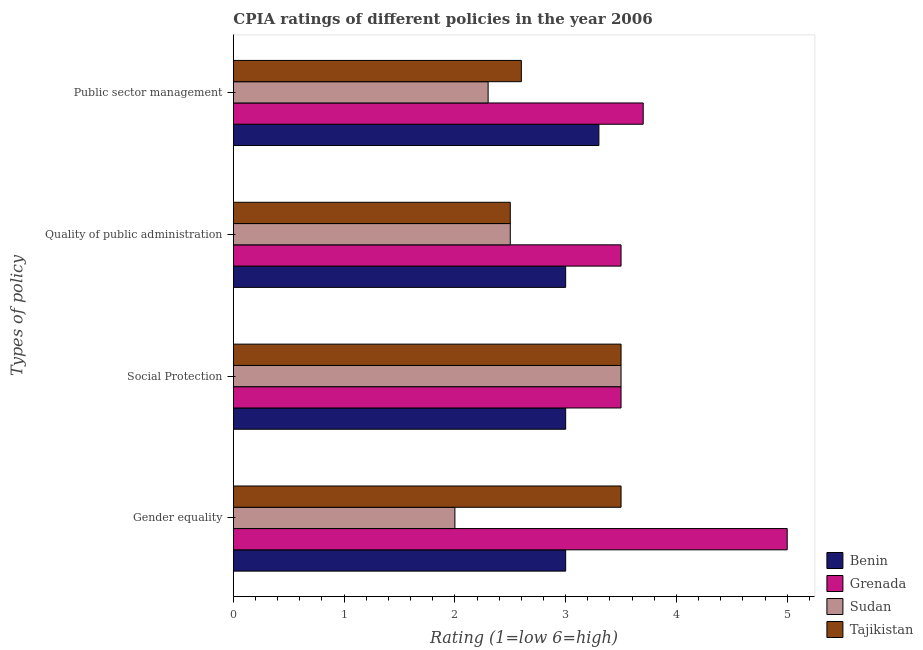How many different coloured bars are there?
Offer a terse response. 4. Are the number of bars on each tick of the Y-axis equal?
Your answer should be very brief. Yes. How many bars are there on the 2nd tick from the top?
Your response must be concise. 4. What is the label of the 4th group of bars from the top?
Give a very brief answer. Gender equality. In which country was the cpia rating of quality of public administration maximum?
Ensure brevity in your answer.  Grenada. In which country was the cpia rating of gender equality minimum?
Provide a succinct answer. Sudan. What is the total cpia rating of gender equality in the graph?
Your response must be concise. 13.5. What is the difference between the cpia rating of social protection in Tajikistan and that in Benin?
Offer a very short reply. 0.5. What is the difference between the cpia rating of quality of public administration in Tajikistan and the cpia rating of public sector management in Sudan?
Ensure brevity in your answer.  0.2. What is the average cpia rating of public sector management per country?
Your response must be concise. 2.98. What is the difference between the cpia rating of social protection and cpia rating of quality of public administration in Grenada?
Offer a very short reply. 0. In how many countries, is the cpia rating of quality of public administration greater than 1.6 ?
Provide a succinct answer. 4. What is the ratio of the cpia rating of quality of public administration in Sudan to that in Grenada?
Your answer should be very brief. 0.71. Is the cpia rating of quality of public administration in Tajikistan less than that in Sudan?
Offer a terse response. No. What is the difference between the highest and the lowest cpia rating of public sector management?
Provide a short and direct response. 1.4. Is the sum of the cpia rating of public sector management in Grenada and Sudan greater than the maximum cpia rating of gender equality across all countries?
Your answer should be compact. Yes. What does the 3rd bar from the top in Quality of public administration represents?
Your answer should be very brief. Grenada. What does the 4th bar from the bottom in Public sector management represents?
Provide a short and direct response. Tajikistan. Is it the case that in every country, the sum of the cpia rating of gender equality and cpia rating of social protection is greater than the cpia rating of quality of public administration?
Make the answer very short. Yes. How many bars are there?
Provide a succinct answer. 16. Are all the bars in the graph horizontal?
Your answer should be very brief. Yes. Does the graph contain grids?
Make the answer very short. No. Where does the legend appear in the graph?
Give a very brief answer. Bottom right. How many legend labels are there?
Offer a very short reply. 4. How are the legend labels stacked?
Offer a terse response. Vertical. What is the title of the graph?
Give a very brief answer. CPIA ratings of different policies in the year 2006. Does "Hong Kong" appear as one of the legend labels in the graph?
Make the answer very short. No. What is the label or title of the Y-axis?
Offer a terse response. Types of policy. What is the Rating (1=low 6=high) of Benin in Gender equality?
Your response must be concise. 3. What is the Rating (1=low 6=high) of Grenada in Gender equality?
Give a very brief answer. 5. What is the Rating (1=low 6=high) in Grenada in Social Protection?
Give a very brief answer. 3.5. What is the Rating (1=low 6=high) of Sudan in Social Protection?
Ensure brevity in your answer.  3.5. What is the Rating (1=low 6=high) of Benin in Quality of public administration?
Make the answer very short. 3. What is the Rating (1=low 6=high) of Grenada in Quality of public administration?
Offer a terse response. 3.5. What is the Rating (1=low 6=high) in Benin in Public sector management?
Give a very brief answer. 3.3. What is the Rating (1=low 6=high) of Grenada in Public sector management?
Provide a short and direct response. 3.7. Across all Types of policy, what is the maximum Rating (1=low 6=high) of Sudan?
Give a very brief answer. 3.5. Across all Types of policy, what is the maximum Rating (1=low 6=high) in Tajikistan?
Keep it short and to the point. 3.5. Across all Types of policy, what is the minimum Rating (1=low 6=high) in Tajikistan?
Your response must be concise. 2.5. What is the total Rating (1=low 6=high) of Benin in the graph?
Your answer should be compact. 12.3. What is the total Rating (1=low 6=high) in Grenada in the graph?
Make the answer very short. 15.7. What is the total Rating (1=low 6=high) of Tajikistan in the graph?
Provide a short and direct response. 12.1. What is the difference between the Rating (1=low 6=high) of Tajikistan in Gender equality and that in Social Protection?
Offer a terse response. 0. What is the difference between the Rating (1=low 6=high) of Grenada in Gender equality and that in Quality of public administration?
Ensure brevity in your answer.  1.5. What is the difference between the Rating (1=low 6=high) of Sudan in Gender equality and that in Quality of public administration?
Provide a succinct answer. -0.5. What is the difference between the Rating (1=low 6=high) of Benin in Social Protection and that in Quality of public administration?
Your response must be concise. 0. What is the difference between the Rating (1=low 6=high) of Grenada in Social Protection and that in Quality of public administration?
Provide a succinct answer. 0. What is the difference between the Rating (1=low 6=high) of Tajikistan in Social Protection and that in Quality of public administration?
Provide a succinct answer. 1. What is the difference between the Rating (1=low 6=high) in Benin in Social Protection and that in Public sector management?
Offer a very short reply. -0.3. What is the difference between the Rating (1=low 6=high) of Grenada in Social Protection and that in Public sector management?
Give a very brief answer. -0.2. What is the difference between the Rating (1=low 6=high) of Grenada in Quality of public administration and that in Public sector management?
Offer a very short reply. -0.2. What is the difference between the Rating (1=low 6=high) of Sudan in Quality of public administration and that in Public sector management?
Your answer should be very brief. 0.2. What is the difference between the Rating (1=low 6=high) of Tajikistan in Quality of public administration and that in Public sector management?
Offer a very short reply. -0.1. What is the difference between the Rating (1=low 6=high) of Benin in Gender equality and the Rating (1=low 6=high) of Sudan in Social Protection?
Provide a short and direct response. -0.5. What is the difference between the Rating (1=low 6=high) in Benin in Gender equality and the Rating (1=low 6=high) in Tajikistan in Social Protection?
Your answer should be compact. -0.5. What is the difference between the Rating (1=low 6=high) of Grenada in Gender equality and the Rating (1=low 6=high) of Tajikistan in Social Protection?
Your answer should be very brief. 1.5. What is the difference between the Rating (1=low 6=high) of Benin in Gender equality and the Rating (1=low 6=high) of Tajikistan in Quality of public administration?
Give a very brief answer. 0.5. What is the difference between the Rating (1=low 6=high) in Grenada in Gender equality and the Rating (1=low 6=high) in Sudan in Quality of public administration?
Make the answer very short. 2.5. What is the difference between the Rating (1=low 6=high) in Grenada in Gender equality and the Rating (1=low 6=high) in Tajikistan in Quality of public administration?
Your response must be concise. 2.5. What is the difference between the Rating (1=low 6=high) in Benin in Gender equality and the Rating (1=low 6=high) in Grenada in Public sector management?
Provide a succinct answer. -0.7. What is the difference between the Rating (1=low 6=high) of Benin in Gender equality and the Rating (1=low 6=high) of Sudan in Public sector management?
Give a very brief answer. 0.7. What is the difference between the Rating (1=low 6=high) of Benin in Social Protection and the Rating (1=low 6=high) of Grenada in Quality of public administration?
Give a very brief answer. -0.5. What is the difference between the Rating (1=low 6=high) in Grenada in Social Protection and the Rating (1=low 6=high) in Tajikistan in Quality of public administration?
Provide a succinct answer. 1. What is the difference between the Rating (1=low 6=high) in Benin in Social Protection and the Rating (1=low 6=high) in Sudan in Public sector management?
Provide a short and direct response. 0.7. What is the difference between the Rating (1=low 6=high) in Grenada in Social Protection and the Rating (1=low 6=high) in Sudan in Public sector management?
Your answer should be very brief. 1.2. What is the difference between the Rating (1=low 6=high) in Sudan in Social Protection and the Rating (1=low 6=high) in Tajikistan in Public sector management?
Provide a succinct answer. 0.9. What is the difference between the Rating (1=low 6=high) of Benin in Quality of public administration and the Rating (1=low 6=high) of Sudan in Public sector management?
Your answer should be compact. 0.7. What is the difference between the Rating (1=low 6=high) of Grenada in Quality of public administration and the Rating (1=low 6=high) of Sudan in Public sector management?
Make the answer very short. 1.2. What is the difference between the Rating (1=low 6=high) in Sudan in Quality of public administration and the Rating (1=low 6=high) in Tajikistan in Public sector management?
Ensure brevity in your answer.  -0.1. What is the average Rating (1=low 6=high) of Benin per Types of policy?
Your response must be concise. 3.08. What is the average Rating (1=low 6=high) of Grenada per Types of policy?
Your answer should be compact. 3.92. What is the average Rating (1=low 6=high) in Sudan per Types of policy?
Provide a succinct answer. 2.58. What is the average Rating (1=low 6=high) of Tajikistan per Types of policy?
Ensure brevity in your answer.  3.02. What is the difference between the Rating (1=low 6=high) in Benin and Rating (1=low 6=high) in Grenada in Gender equality?
Provide a succinct answer. -2. What is the difference between the Rating (1=low 6=high) of Grenada and Rating (1=low 6=high) of Sudan in Gender equality?
Your response must be concise. 3. What is the difference between the Rating (1=low 6=high) of Sudan and Rating (1=low 6=high) of Tajikistan in Gender equality?
Give a very brief answer. -1.5. What is the difference between the Rating (1=low 6=high) in Benin and Rating (1=low 6=high) in Tajikistan in Social Protection?
Provide a short and direct response. -0.5. What is the difference between the Rating (1=low 6=high) in Grenada and Rating (1=low 6=high) in Tajikistan in Social Protection?
Provide a succinct answer. 0. What is the difference between the Rating (1=low 6=high) of Benin and Rating (1=low 6=high) of Sudan in Quality of public administration?
Offer a very short reply. 0.5. What is the difference between the Rating (1=low 6=high) of Benin and Rating (1=low 6=high) of Grenada in Public sector management?
Give a very brief answer. -0.4. What is the difference between the Rating (1=low 6=high) in Benin and Rating (1=low 6=high) in Sudan in Public sector management?
Your answer should be compact. 1. What is the difference between the Rating (1=low 6=high) in Benin and Rating (1=low 6=high) in Tajikistan in Public sector management?
Your answer should be compact. 0.7. What is the difference between the Rating (1=low 6=high) of Grenada and Rating (1=low 6=high) of Sudan in Public sector management?
Give a very brief answer. 1.4. What is the difference between the Rating (1=low 6=high) of Grenada and Rating (1=low 6=high) of Tajikistan in Public sector management?
Your answer should be very brief. 1.1. What is the difference between the Rating (1=low 6=high) of Sudan and Rating (1=low 6=high) of Tajikistan in Public sector management?
Keep it short and to the point. -0.3. What is the ratio of the Rating (1=low 6=high) in Grenada in Gender equality to that in Social Protection?
Your response must be concise. 1.43. What is the ratio of the Rating (1=low 6=high) of Grenada in Gender equality to that in Quality of public administration?
Your answer should be very brief. 1.43. What is the ratio of the Rating (1=low 6=high) of Benin in Gender equality to that in Public sector management?
Provide a succinct answer. 0.91. What is the ratio of the Rating (1=low 6=high) of Grenada in Gender equality to that in Public sector management?
Offer a terse response. 1.35. What is the ratio of the Rating (1=low 6=high) of Sudan in Gender equality to that in Public sector management?
Your response must be concise. 0.87. What is the ratio of the Rating (1=low 6=high) in Tajikistan in Gender equality to that in Public sector management?
Provide a short and direct response. 1.35. What is the ratio of the Rating (1=low 6=high) of Grenada in Social Protection to that in Quality of public administration?
Offer a terse response. 1. What is the ratio of the Rating (1=low 6=high) in Sudan in Social Protection to that in Quality of public administration?
Ensure brevity in your answer.  1.4. What is the ratio of the Rating (1=low 6=high) in Tajikistan in Social Protection to that in Quality of public administration?
Ensure brevity in your answer.  1.4. What is the ratio of the Rating (1=low 6=high) of Grenada in Social Protection to that in Public sector management?
Provide a short and direct response. 0.95. What is the ratio of the Rating (1=low 6=high) in Sudan in Social Protection to that in Public sector management?
Keep it short and to the point. 1.52. What is the ratio of the Rating (1=low 6=high) in Tajikistan in Social Protection to that in Public sector management?
Your answer should be compact. 1.35. What is the ratio of the Rating (1=low 6=high) of Grenada in Quality of public administration to that in Public sector management?
Keep it short and to the point. 0.95. What is the ratio of the Rating (1=low 6=high) of Sudan in Quality of public administration to that in Public sector management?
Your response must be concise. 1.09. What is the ratio of the Rating (1=low 6=high) of Tajikistan in Quality of public administration to that in Public sector management?
Provide a succinct answer. 0.96. What is the difference between the highest and the second highest Rating (1=low 6=high) of Benin?
Your answer should be compact. 0.3. What is the difference between the highest and the second highest Rating (1=low 6=high) in Grenada?
Provide a short and direct response. 1.3. What is the difference between the highest and the second highest Rating (1=low 6=high) of Tajikistan?
Offer a very short reply. 0. 